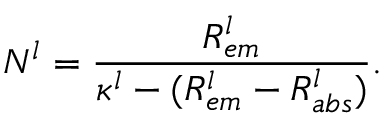<formula> <loc_0><loc_0><loc_500><loc_500>N ^ { l } = \frac { R _ { e m } ^ { l } } { \kappa ^ { l } - ( R _ { e m } ^ { l } - R _ { a b s } ^ { l } ) } .</formula> 